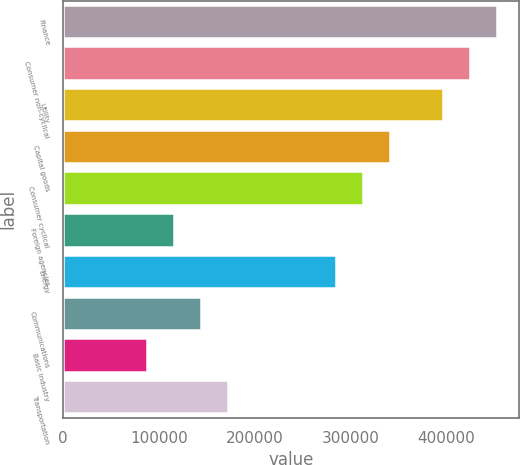<chart> <loc_0><loc_0><loc_500><loc_500><bar_chart><fcel>Finance<fcel>Consumer non-cyclical<fcel>Utility<fcel>Capital goods<fcel>Consumer cyclical<fcel>Foreign agencies<fcel>Energy<fcel>Communications<fcel>Basic industry<fcel>Transportation<nl><fcel>453406<fcel>425305<fcel>397204<fcel>341001<fcel>312900<fcel>116192<fcel>284799<fcel>144293<fcel>88090.6<fcel>172394<nl></chart> 